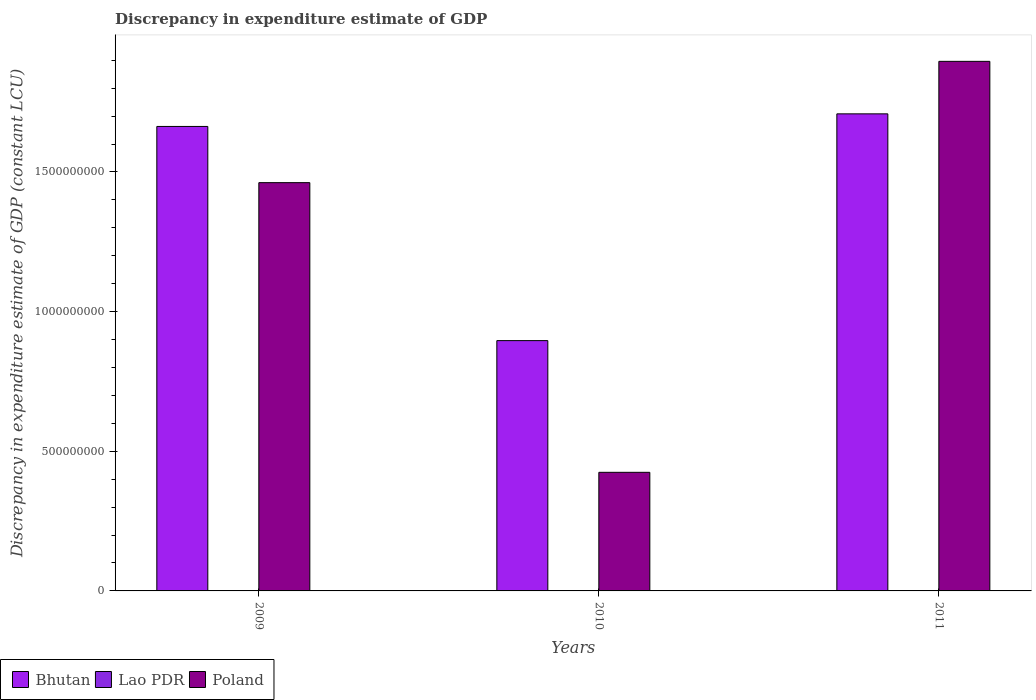How many different coloured bars are there?
Offer a terse response. 3. Are the number of bars on each tick of the X-axis equal?
Provide a short and direct response. No. How many bars are there on the 1st tick from the left?
Provide a short and direct response. 2. What is the label of the 3rd group of bars from the left?
Your response must be concise. 2011. In how many cases, is the number of bars for a given year not equal to the number of legend labels?
Your answer should be compact. 1. Across all years, what is the maximum discrepancy in expenditure estimate of GDP in Poland?
Your response must be concise. 1.90e+09. Across all years, what is the minimum discrepancy in expenditure estimate of GDP in Bhutan?
Keep it short and to the point. 8.96e+08. In which year was the discrepancy in expenditure estimate of GDP in Poland maximum?
Your answer should be very brief. 2011. What is the total discrepancy in expenditure estimate of GDP in Bhutan in the graph?
Offer a very short reply. 4.27e+09. What is the difference between the discrepancy in expenditure estimate of GDP in Bhutan in 2010 and that in 2011?
Keep it short and to the point. -8.12e+08. What is the difference between the discrepancy in expenditure estimate of GDP in Lao PDR in 2010 and the discrepancy in expenditure estimate of GDP in Poland in 2009?
Provide a short and direct response. -1.46e+09. What is the average discrepancy in expenditure estimate of GDP in Poland per year?
Give a very brief answer. 1.26e+09. In the year 2011, what is the difference between the discrepancy in expenditure estimate of GDP in Lao PDR and discrepancy in expenditure estimate of GDP in Bhutan?
Your response must be concise. -1.71e+09. In how many years, is the discrepancy in expenditure estimate of GDP in Bhutan greater than 900000000 LCU?
Ensure brevity in your answer.  2. What is the ratio of the discrepancy in expenditure estimate of GDP in Lao PDR in 2010 to that in 2011?
Your response must be concise. 1. Is the difference between the discrepancy in expenditure estimate of GDP in Lao PDR in 2010 and 2011 greater than the difference between the discrepancy in expenditure estimate of GDP in Bhutan in 2010 and 2011?
Your answer should be very brief. Yes. What is the difference between the highest and the second highest discrepancy in expenditure estimate of GDP in Bhutan?
Provide a succinct answer. 4.51e+07. What is the difference between the highest and the lowest discrepancy in expenditure estimate of GDP in Bhutan?
Offer a terse response. 8.12e+08. Is the sum of the discrepancy in expenditure estimate of GDP in Poland in 2010 and 2011 greater than the maximum discrepancy in expenditure estimate of GDP in Lao PDR across all years?
Keep it short and to the point. Yes. Is it the case that in every year, the sum of the discrepancy in expenditure estimate of GDP in Lao PDR and discrepancy in expenditure estimate of GDP in Poland is greater than the discrepancy in expenditure estimate of GDP in Bhutan?
Your answer should be compact. No. Are all the bars in the graph horizontal?
Make the answer very short. No. How many years are there in the graph?
Ensure brevity in your answer.  3. Are the values on the major ticks of Y-axis written in scientific E-notation?
Give a very brief answer. No. Does the graph contain grids?
Your answer should be compact. No. Where does the legend appear in the graph?
Ensure brevity in your answer.  Bottom left. How many legend labels are there?
Give a very brief answer. 3. What is the title of the graph?
Make the answer very short. Discrepancy in expenditure estimate of GDP. What is the label or title of the Y-axis?
Provide a succinct answer. Discrepancy in expenditure estimate of GDP (constant LCU). What is the Discrepancy in expenditure estimate of GDP (constant LCU) in Bhutan in 2009?
Keep it short and to the point. 1.66e+09. What is the Discrepancy in expenditure estimate of GDP (constant LCU) in Lao PDR in 2009?
Ensure brevity in your answer.  0. What is the Discrepancy in expenditure estimate of GDP (constant LCU) of Poland in 2009?
Provide a succinct answer. 1.46e+09. What is the Discrepancy in expenditure estimate of GDP (constant LCU) of Bhutan in 2010?
Your answer should be very brief. 8.96e+08. What is the Discrepancy in expenditure estimate of GDP (constant LCU) of Lao PDR in 2010?
Keep it short and to the point. 100. What is the Discrepancy in expenditure estimate of GDP (constant LCU) of Poland in 2010?
Keep it short and to the point. 4.25e+08. What is the Discrepancy in expenditure estimate of GDP (constant LCU) of Bhutan in 2011?
Make the answer very short. 1.71e+09. What is the Discrepancy in expenditure estimate of GDP (constant LCU) in Lao PDR in 2011?
Provide a short and direct response. 100. What is the Discrepancy in expenditure estimate of GDP (constant LCU) of Poland in 2011?
Provide a short and direct response. 1.90e+09. Across all years, what is the maximum Discrepancy in expenditure estimate of GDP (constant LCU) in Bhutan?
Ensure brevity in your answer.  1.71e+09. Across all years, what is the maximum Discrepancy in expenditure estimate of GDP (constant LCU) of Lao PDR?
Your answer should be very brief. 100. Across all years, what is the maximum Discrepancy in expenditure estimate of GDP (constant LCU) of Poland?
Your answer should be compact. 1.90e+09. Across all years, what is the minimum Discrepancy in expenditure estimate of GDP (constant LCU) in Bhutan?
Provide a short and direct response. 8.96e+08. Across all years, what is the minimum Discrepancy in expenditure estimate of GDP (constant LCU) in Poland?
Your answer should be very brief. 4.25e+08. What is the total Discrepancy in expenditure estimate of GDP (constant LCU) in Bhutan in the graph?
Provide a short and direct response. 4.27e+09. What is the total Discrepancy in expenditure estimate of GDP (constant LCU) in Lao PDR in the graph?
Ensure brevity in your answer.  200. What is the total Discrepancy in expenditure estimate of GDP (constant LCU) in Poland in the graph?
Your answer should be very brief. 3.78e+09. What is the difference between the Discrepancy in expenditure estimate of GDP (constant LCU) in Bhutan in 2009 and that in 2010?
Your answer should be very brief. 7.67e+08. What is the difference between the Discrepancy in expenditure estimate of GDP (constant LCU) in Poland in 2009 and that in 2010?
Your response must be concise. 1.04e+09. What is the difference between the Discrepancy in expenditure estimate of GDP (constant LCU) of Bhutan in 2009 and that in 2011?
Ensure brevity in your answer.  -4.51e+07. What is the difference between the Discrepancy in expenditure estimate of GDP (constant LCU) of Poland in 2009 and that in 2011?
Provide a succinct answer. -4.34e+08. What is the difference between the Discrepancy in expenditure estimate of GDP (constant LCU) of Bhutan in 2010 and that in 2011?
Give a very brief answer. -8.12e+08. What is the difference between the Discrepancy in expenditure estimate of GDP (constant LCU) of Lao PDR in 2010 and that in 2011?
Your answer should be very brief. 0. What is the difference between the Discrepancy in expenditure estimate of GDP (constant LCU) in Poland in 2010 and that in 2011?
Provide a short and direct response. -1.47e+09. What is the difference between the Discrepancy in expenditure estimate of GDP (constant LCU) of Bhutan in 2009 and the Discrepancy in expenditure estimate of GDP (constant LCU) of Lao PDR in 2010?
Your response must be concise. 1.66e+09. What is the difference between the Discrepancy in expenditure estimate of GDP (constant LCU) of Bhutan in 2009 and the Discrepancy in expenditure estimate of GDP (constant LCU) of Poland in 2010?
Provide a succinct answer. 1.24e+09. What is the difference between the Discrepancy in expenditure estimate of GDP (constant LCU) in Bhutan in 2009 and the Discrepancy in expenditure estimate of GDP (constant LCU) in Lao PDR in 2011?
Keep it short and to the point. 1.66e+09. What is the difference between the Discrepancy in expenditure estimate of GDP (constant LCU) of Bhutan in 2009 and the Discrepancy in expenditure estimate of GDP (constant LCU) of Poland in 2011?
Keep it short and to the point. -2.33e+08. What is the difference between the Discrepancy in expenditure estimate of GDP (constant LCU) of Bhutan in 2010 and the Discrepancy in expenditure estimate of GDP (constant LCU) of Lao PDR in 2011?
Give a very brief answer. 8.96e+08. What is the difference between the Discrepancy in expenditure estimate of GDP (constant LCU) of Bhutan in 2010 and the Discrepancy in expenditure estimate of GDP (constant LCU) of Poland in 2011?
Provide a short and direct response. -1.00e+09. What is the difference between the Discrepancy in expenditure estimate of GDP (constant LCU) in Lao PDR in 2010 and the Discrepancy in expenditure estimate of GDP (constant LCU) in Poland in 2011?
Make the answer very short. -1.90e+09. What is the average Discrepancy in expenditure estimate of GDP (constant LCU) in Bhutan per year?
Provide a succinct answer. 1.42e+09. What is the average Discrepancy in expenditure estimate of GDP (constant LCU) of Lao PDR per year?
Your response must be concise. 66.67. What is the average Discrepancy in expenditure estimate of GDP (constant LCU) of Poland per year?
Your answer should be very brief. 1.26e+09. In the year 2009, what is the difference between the Discrepancy in expenditure estimate of GDP (constant LCU) of Bhutan and Discrepancy in expenditure estimate of GDP (constant LCU) of Poland?
Provide a short and direct response. 2.01e+08. In the year 2010, what is the difference between the Discrepancy in expenditure estimate of GDP (constant LCU) of Bhutan and Discrepancy in expenditure estimate of GDP (constant LCU) of Lao PDR?
Ensure brevity in your answer.  8.96e+08. In the year 2010, what is the difference between the Discrepancy in expenditure estimate of GDP (constant LCU) of Bhutan and Discrepancy in expenditure estimate of GDP (constant LCU) of Poland?
Give a very brief answer. 4.72e+08. In the year 2010, what is the difference between the Discrepancy in expenditure estimate of GDP (constant LCU) in Lao PDR and Discrepancy in expenditure estimate of GDP (constant LCU) in Poland?
Provide a succinct answer. -4.25e+08. In the year 2011, what is the difference between the Discrepancy in expenditure estimate of GDP (constant LCU) in Bhutan and Discrepancy in expenditure estimate of GDP (constant LCU) in Lao PDR?
Provide a succinct answer. 1.71e+09. In the year 2011, what is the difference between the Discrepancy in expenditure estimate of GDP (constant LCU) in Bhutan and Discrepancy in expenditure estimate of GDP (constant LCU) in Poland?
Provide a succinct answer. -1.88e+08. In the year 2011, what is the difference between the Discrepancy in expenditure estimate of GDP (constant LCU) in Lao PDR and Discrepancy in expenditure estimate of GDP (constant LCU) in Poland?
Ensure brevity in your answer.  -1.90e+09. What is the ratio of the Discrepancy in expenditure estimate of GDP (constant LCU) in Bhutan in 2009 to that in 2010?
Your answer should be very brief. 1.86. What is the ratio of the Discrepancy in expenditure estimate of GDP (constant LCU) of Poland in 2009 to that in 2010?
Your answer should be very brief. 3.44. What is the ratio of the Discrepancy in expenditure estimate of GDP (constant LCU) in Bhutan in 2009 to that in 2011?
Offer a very short reply. 0.97. What is the ratio of the Discrepancy in expenditure estimate of GDP (constant LCU) of Poland in 2009 to that in 2011?
Your answer should be very brief. 0.77. What is the ratio of the Discrepancy in expenditure estimate of GDP (constant LCU) in Bhutan in 2010 to that in 2011?
Your response must be concise. 0.52. What is the ratio of the Discrepancy in expenditure estimate of GDP (constant LCU) in Poland in 2010 to that in 2011?
Make the answer very short. 0.22. What is the difference between the highest and the second highest Discrepancy in expenditure estimate of GDP (constant LCU) in Bhutan?
Keep it short and to the point. 4.51e+07. What is the difference between the highest and the second highest Discrepancy in expenditure estimate of GDP (constant LCU) of Poland?
Ensure brevity in your answer.  4.34e+08. What is the difference between the highest and the lowest Discrepancy in expenditure estimate of GDP (constant LCU) in Bhutan?
Keep it short and to the point. 8.12e+08. What is the difference between the highest and the lowest Discrepancy in expenditure estimate of GDP (constant LCU) of Poland?
Your answer should be very brief. 1.47e+09. 